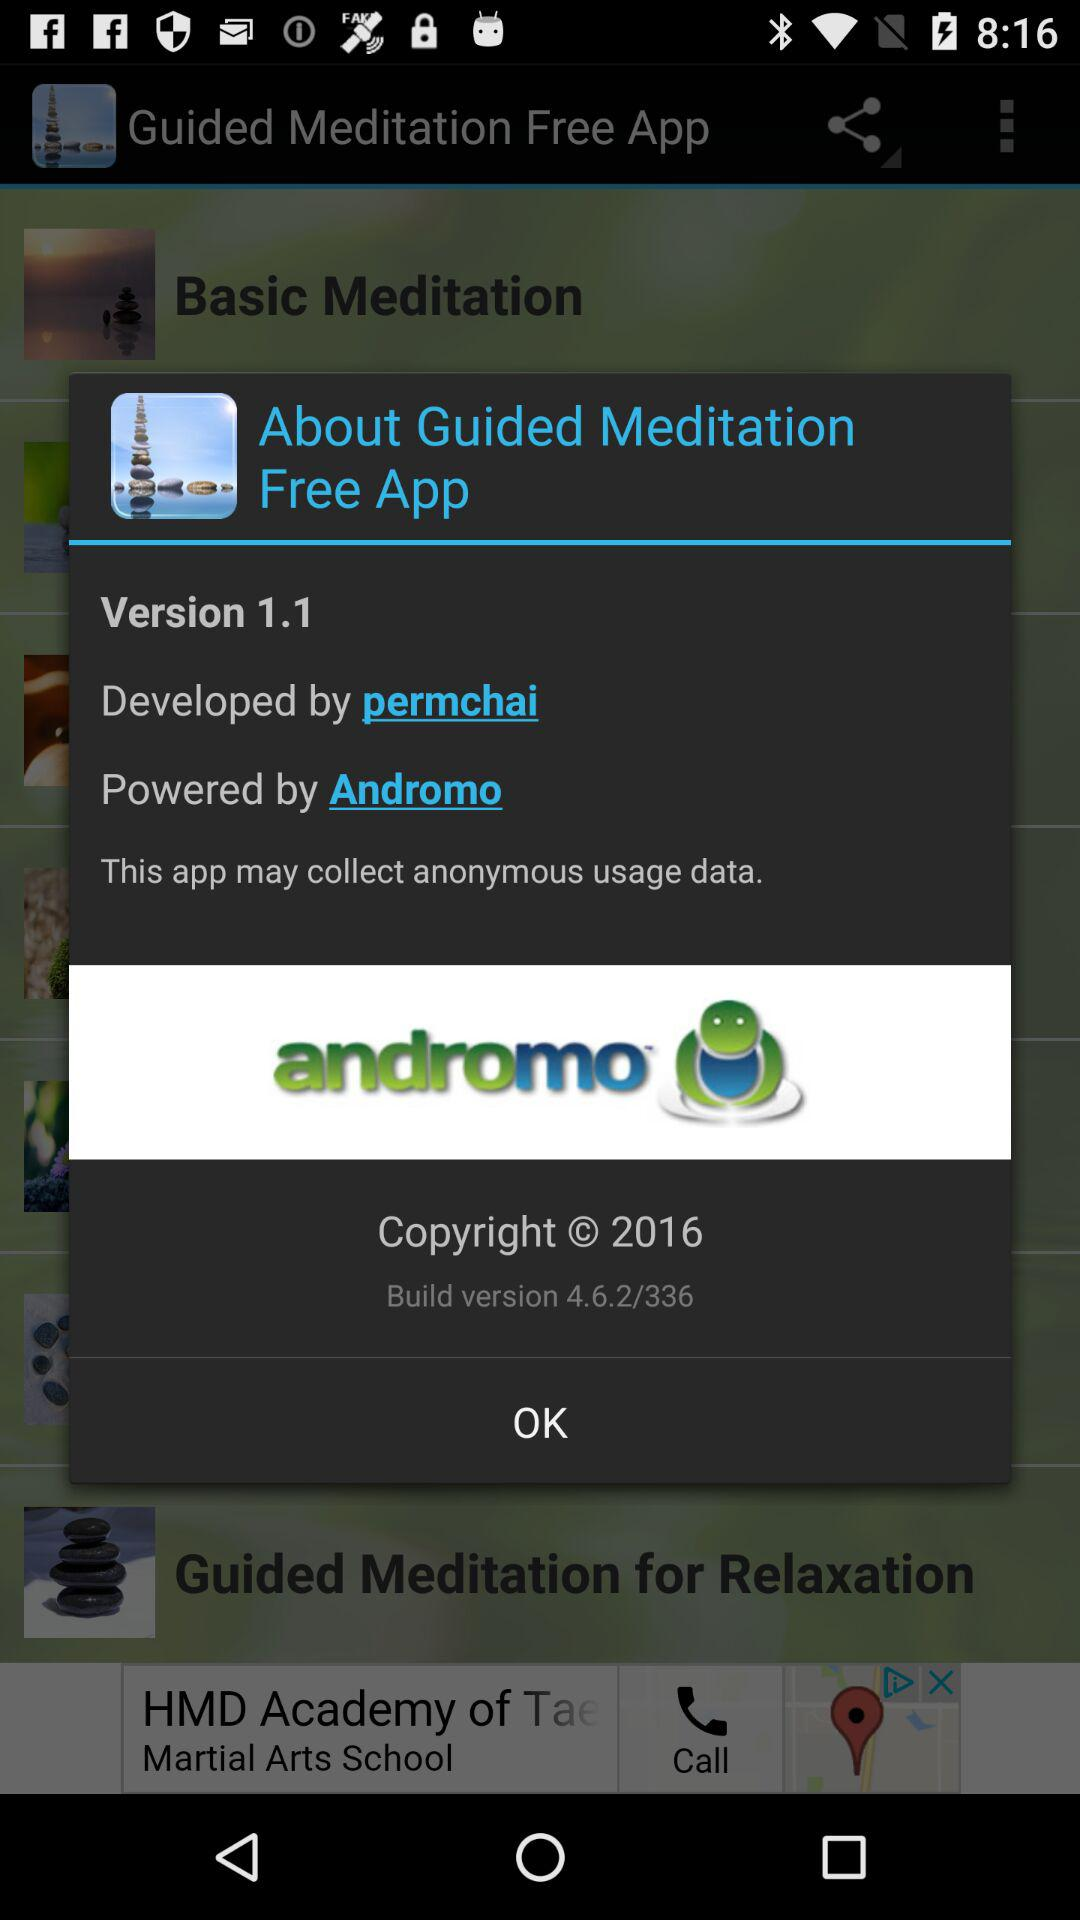What is the version? The version is 1.1. 